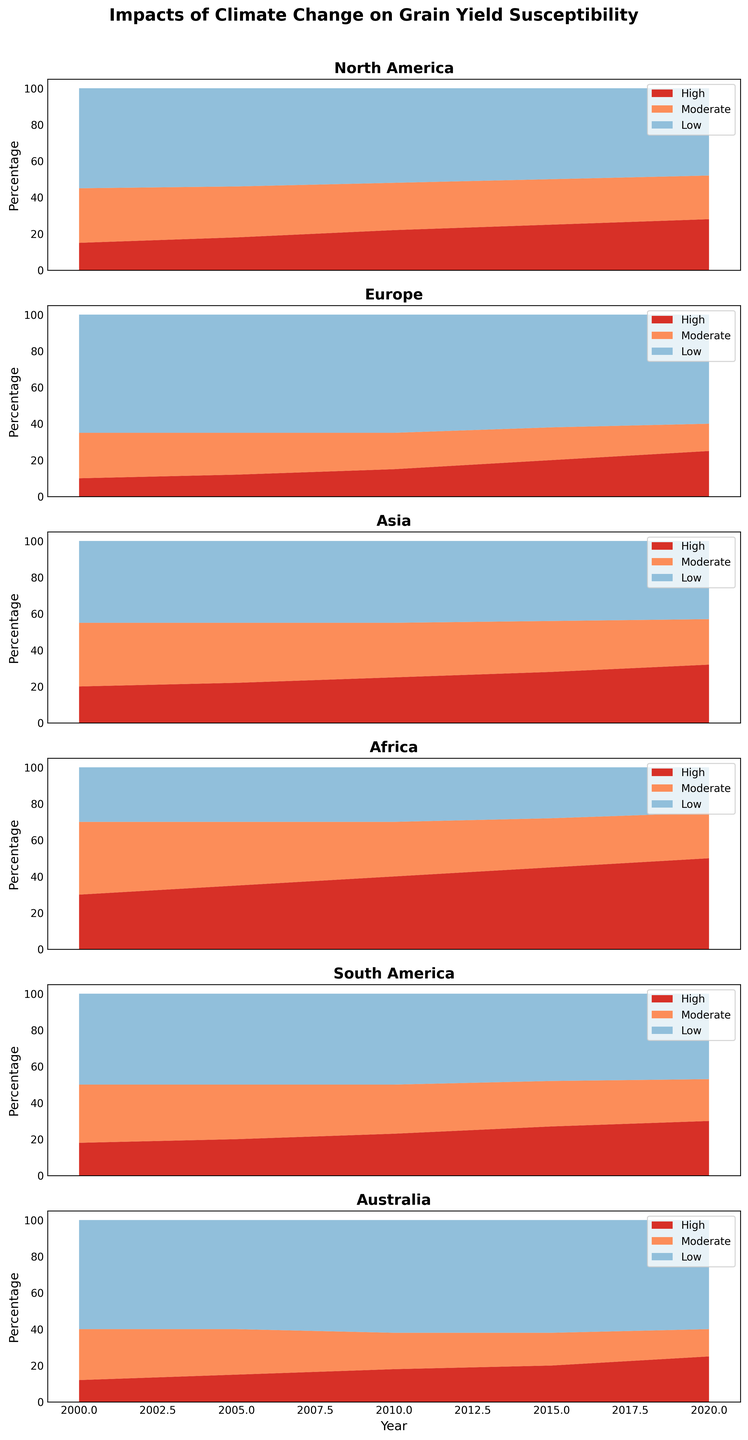What trend do you observe in the percentage of high susceptibility for Asia from 2000 to 2020? By observing the area chart for Asia, we see that the red area, representing high susceptibility, consistently increases from about 20% in 2000 to roughly 32% in 2020.
Answer: Increasing trend Compare the level of low susceptibility in Europe and Africa in 2020. Which region has a higher percentage of low susceptibility? By comparing the blue areas in both charts for 2020, Europe has a larger blue area than Africa. Europe’s low susceptibility is around 60% in 2020, whereas Africa’s is around 25%.
Answer: Europe How does the trend in moderate susceptibility for North America change from 2000 to 2020? The orange area in the North America chart, representing moderate susceptibility, slightly decreases from 30% in 2000 to 24% in 2020, indicating a downward trend.
Answer: Downward trend What is the sum of high and moderate susceptibility for South America in 2010? By looking at the chart for South America in 2010, the red area (high susceptibility) is 23% and the orange area (moderate susceptibility) is 27%. Summing these percentages gives 23% + 27% = 50%.
Answer: 50% Between the years 2000 and 2020, which region has the most significant increase in high susceptibility? By examining all the charts, Africa shows the most substantial increase in the red area representing high susceptibility, going from 30% in 2000 to 50% in 2020. No other region has such a steep increase.
Answer: Africa What is the difference between the percentage of low susceptibility in Australia and North America in 2015? In 2015, Australia’s chart shows a blue area representing 62% low susceptibility, while North America’s shows 50%. The difference is 62% - 50% = 12%.
Answer: 12% Compare the trends in high susceptibility between Europe and South America. Which region shows a more rapid increase? In Europe, the red area increases from 10% in 2000 to 25% in 2020, a 15% rise. In South America, it increases from 18% to 30%, a 12% rise. Therefore, Europe exhibits a more rapid increase in high susceptibility.
Answer: Europe 